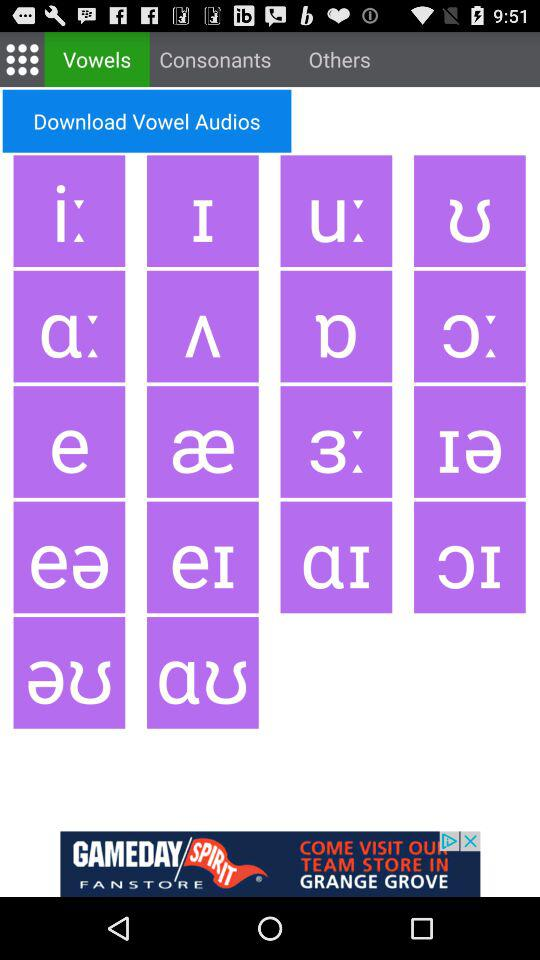How many consonants are there?
When the provided information is insufficient, respond with <no answer>. <no answer> 